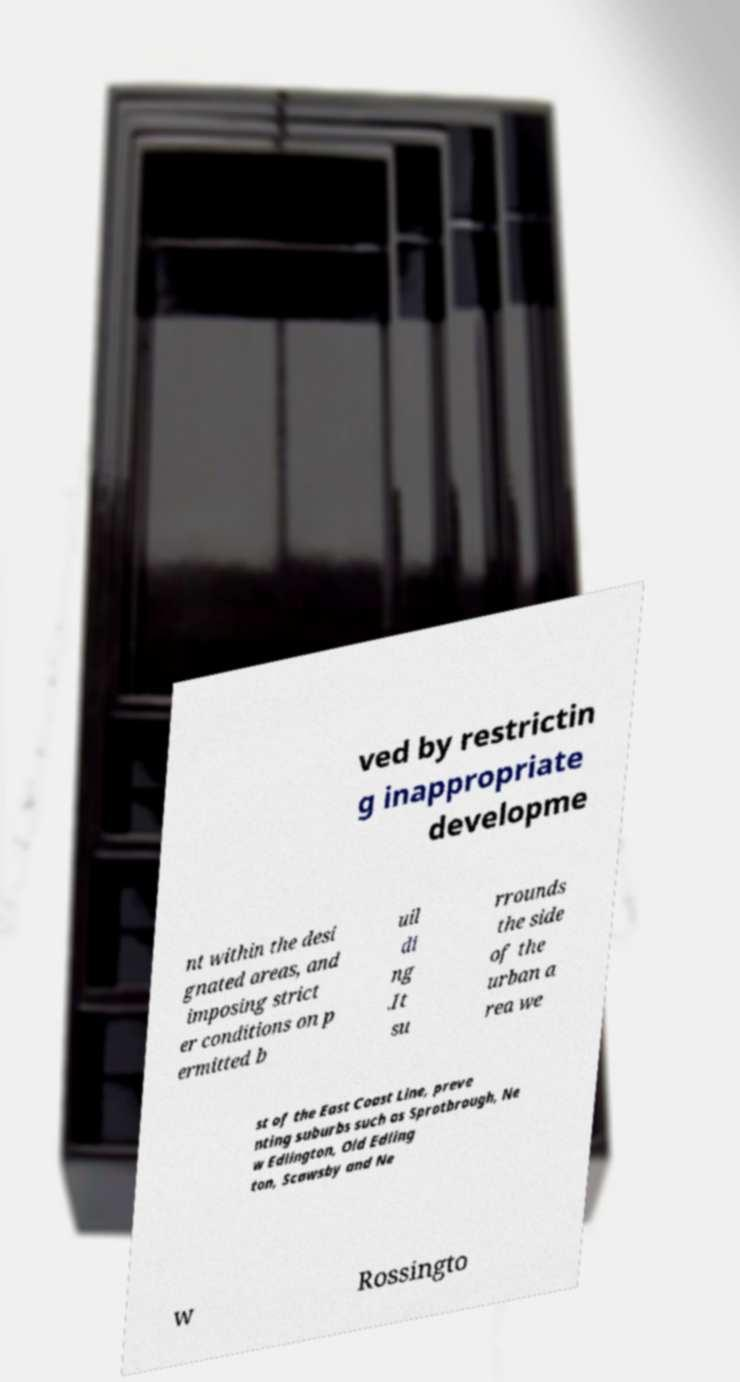Please read and relay the text visible in this image. What does it say? ved by restrictin g inappropriate developme nt within the desi gnated areas, and imposing strict er conditions on p ermitted b uil di ng .It su rrounds the side of the urban a rea we st of the East Coast Line, preve nting suburbs such as Sprotbrough, Ne w Edlington, Old Edling ton, Scawsby and Ne w Rossingto 